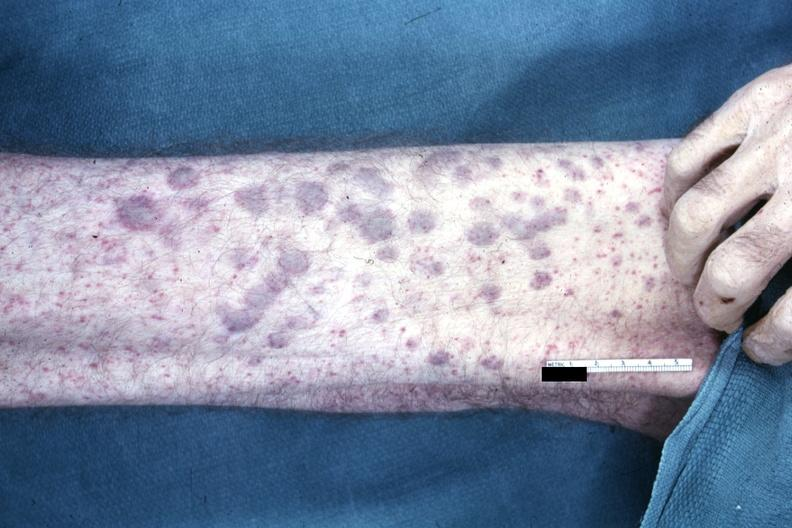what is not best color rendition showing elevated macular lesions on arm said?
Answer the question using a single word or phrase. To be aml infiltrates 